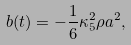Convert formula to latex. <formula><loc_0><loc_0><loc_500><loc_500>b ( t ) = - \frac { 1 } { 6 } \kappa _ { 5 } ^ { 2 } \rho a ^ { 2 } ,</formula> 